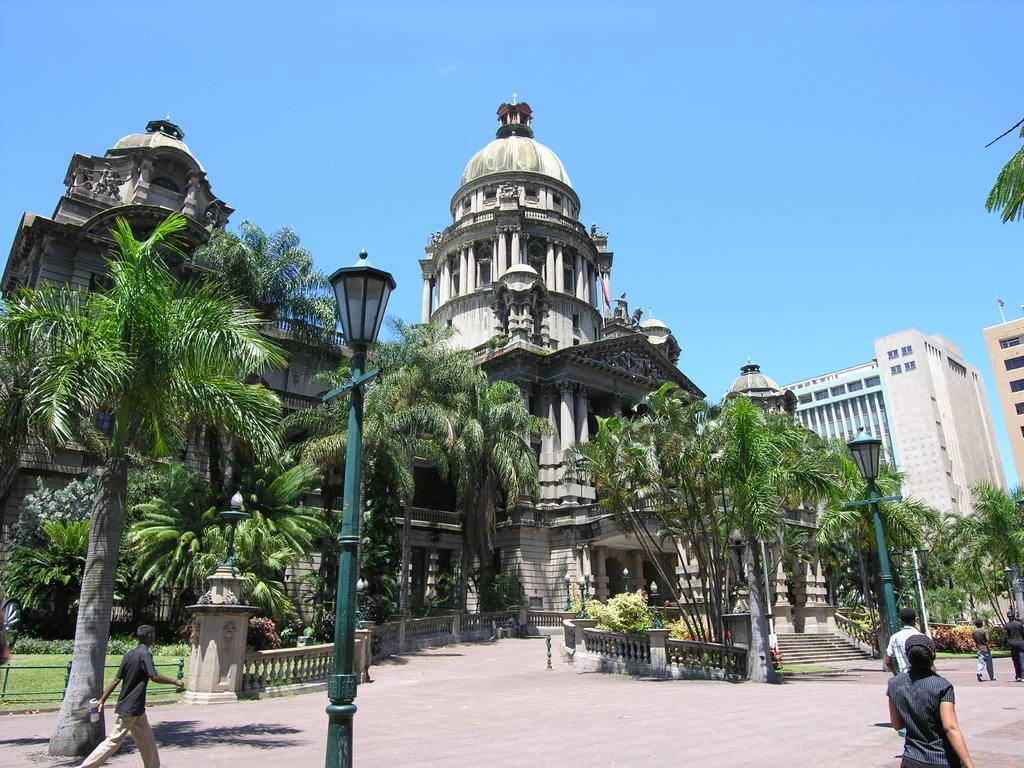Could you give a brief overview of what you see in this image? In this image we can see a few people and buildings, there are some poles with lights, plants, trees, pillars, grass and a staircase. In the background, we can see the sky. 